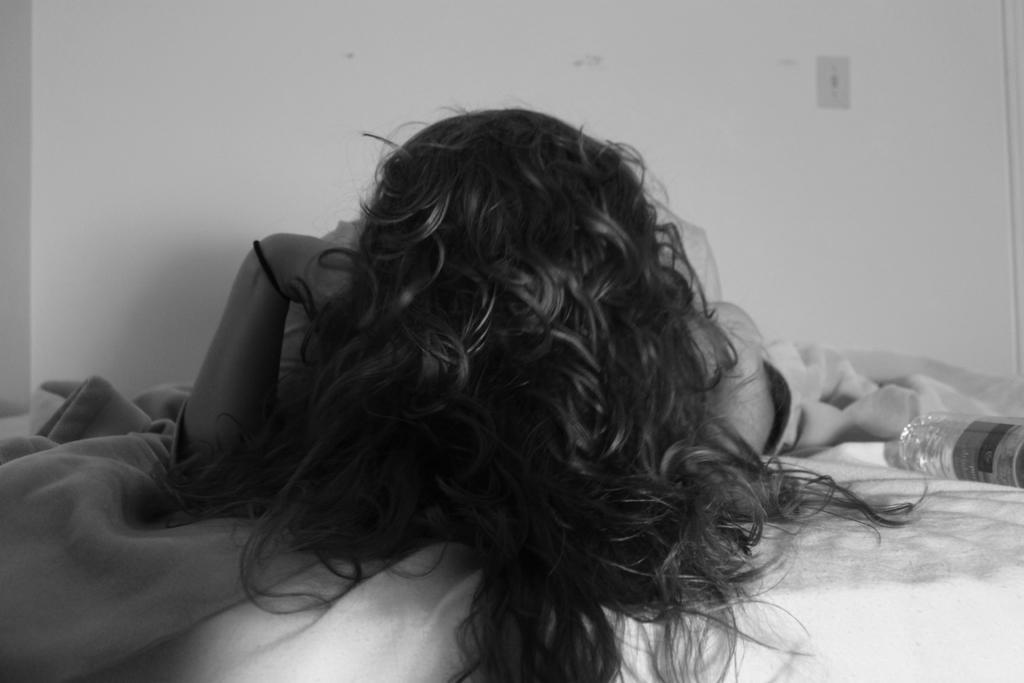In one or two sentences, can you explain what this image depicts? In the center of the image a person is lying on the bed. On the right side of the image a bottle is there. On the left side of the image a blanket is present. At the top of the image wall is there. 